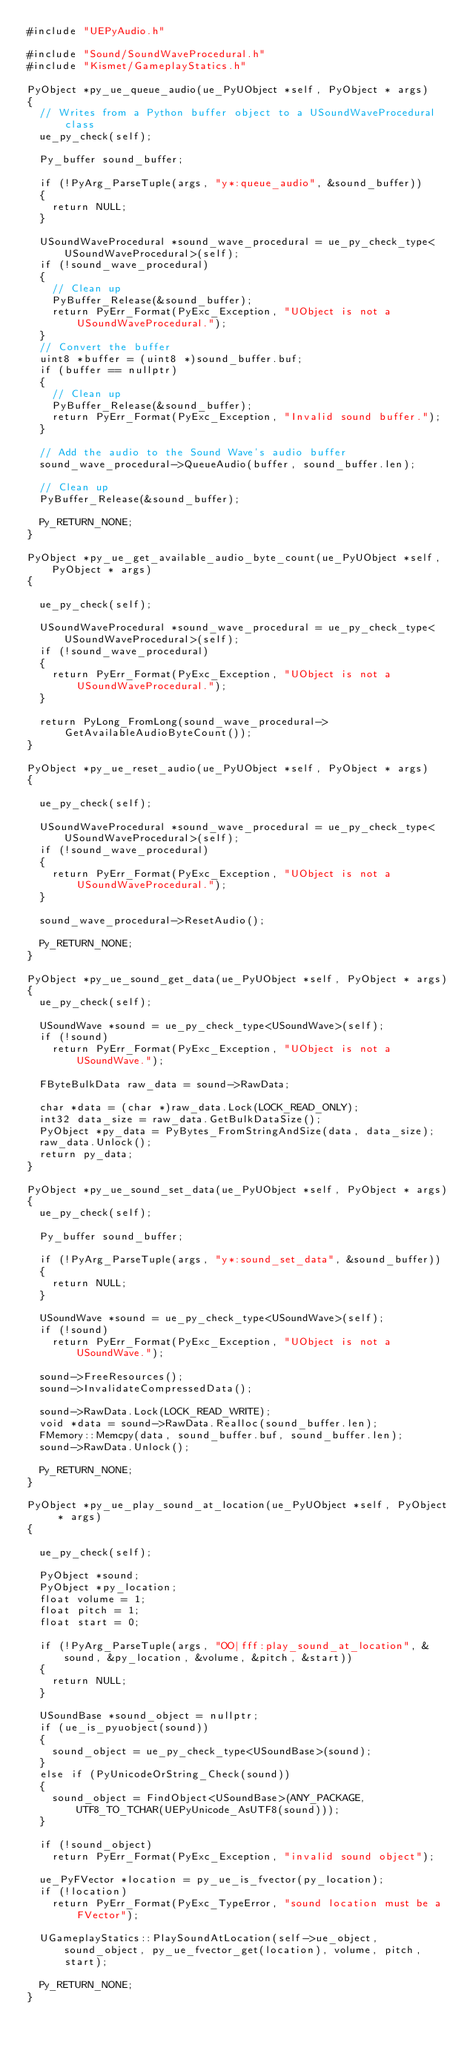Convert code to text. <code><loc_0><loc_0><loc_500><loc_500><_C++_>#include "UEPyAudio.h"

#include "Sound/SoundWaveProcedural.h"
#include "Kismet/GameplayStatics.h"

PyObject *py_ue_queue_audio(ue_PyUObject *self, PyObject * args)
{
	// Writes from a Python buffer object to a USoundWaveProcedural class
	ue_py_check(self);

	Py_buffer sound_buffer;

	if (!PyArg_ParseTuple(args, "y*:queue_audio", &sound_buffer))
	{
		return NULL;
	}

	USoundWaveProcedural *sound_wave_procedural = ue_py_check_type<USoundWaveProcedural>(self);
	if (!sound_wave_procedural)
	{
		// Clean up
		PyBuffer_Release(&sound_buffer);
		return PyErr_Format(PyExc_Exception, "UObject is not a USoundWaveProcedural.");
	}
	// Convert the buffer
	uint8 *buffer = (uint8 *)sound_buffer.buf;
	if (buffer == nullptr)
	{
		// Clean up
		PyBuffer_Release(&sound_buffer);
		return PyErr_Format(PyExc_Exception, "Invalid sound buffer.");
	}

	// Add the audio to the Sound Wave's audio buffer
	sound_wave_procedural->QueueAudio(buffer, sound_buffer.len);

	// Clean up
	PyBuffer_Release(&sound_buffer);

	Py_RETURN_NONE;
}

PyObject *py_ue_get_available_audio_byte_count(ue_PyUObject *self, PyObject * args)
{

	ue_py_check(self);

	USoundWaveProcedural *sound_wave_procedural = ue_py_check_type<USoundWaveProcedural>(self);
	if (!sound_wave_procedural)
	{
		return PyErr_Format(PyExc_Exception, "UObject is not a USoundWaveProcedural.");
	}

	return PyLong_FromLong(sound_wave_procedural->GetAvailableAudioByteCount());
}

PyObject *py_ue_reset_audio(ue_PyUObject *self, PyObject * args)
{

	ue_py_check(self);

	USoundWaveProcedural *sound_wave_procedural = ue_py_check_type<USoundWaveProcedural>(self);
	if (!sound_wave_procedural)
	{
		return PyErr_Format(PyExc_Exception, "UObject is not a USoundWaveProcedural.");
	}

	sound_wave_procedural->ResetAudio();

	Py_RETURN_NONE;
}

PyObject *py_ue_sound_get_data(ue_PyUObject *self, PyObject * args)
{
	ue_py_check(self);

	USoundWave *sound = ue_py_check_type<USoundWave>(self);
	if (!sound)
		return PyErr_Format(PyExc_Exception, "UObject is not a USoundWave.");

	FByteBulkData raw_data = sound->RawData;

	char *data = (char *)raw_data.Lock(LOCK_READ_ONLY);
	int32 data_size = raw_data.GetBulkDataSize();
	PyObject *py_data = PyBytes_FromStringAndSize(data, data_size);
	raw_data.Unlock();
	return py_data;
}

PyObject *py_ue_sound_set_data(ue_PyUObject *self, PyObject * args)
{
	ue_py_check(self);

	Py_buffer sound_buffer;

	if (!PyArg_ParseTuple(args, "y*:sound_set_data", &sound_buffer))
	{
		return NULL;
	}

	USoundWave *sound = ue_py_check_type<USoundWave>(self);
	if (!sound)
		return PyErr_Format(PyExc_Exception, "UObject is not a USoundWave.");

	sound->FreeResources();
	sound->InvalidateCompressedData();

	sound->RawData.Lock(LOCK_READ_WRITE);
	void *data = sound->RawData.Realloc(sound_buffer.len);
	FMemory::Memcpy(data, sound_buffer.buf, sound_buffer.len);
	sound->RawData.Unlock();

	Py_RETURN_NONE;
}

PyObject *py_ue_play_sound_at_location(ue_PyUObject *self, PyObject * args)
{

	ue_py_check(self);

	PyObject *sound;
	PyObject *py_location;
	float volume = 1;
	float pitch = 1;
	float start = 0;

	if (!PyArg_ParseTuple(args, "OO|fff:play_sound_at_location", &sound, &py_location, &volume, &pitch, &start))
	{
		return NULL;
	}

	USoundBase *sound_object = nullptr;
	if (ue_is_pyuobject(sound))
	{
		sound_object = ue_py_check_type<USoundBase>(sound);
	}
	else if (PyUnicodeOrString_Check(sound))
	{
		sound_object = FindObject<USoundBase>(ANY_PACKAGE, UTF8_TO_TCHAR(UEPyUnicode_AsUTF8(sound)));
	}

	if (!sound_object)
		return PyErr_Format(PyExc_Exception, "invalid sound object");

	ue_PyFVector *location = py_ue_is_fvector(py_location);
	if (!location)
		return PyErr_Format(PyExc_TypeError, "sound location must be a FVector");

	UGameplayStatics::PlaySoundAtLocation(self->ue_object, sound_object, py_ue_fvector_get(location), volume, pitch, start);

	Py_RETURN_NONE;
}</code> 